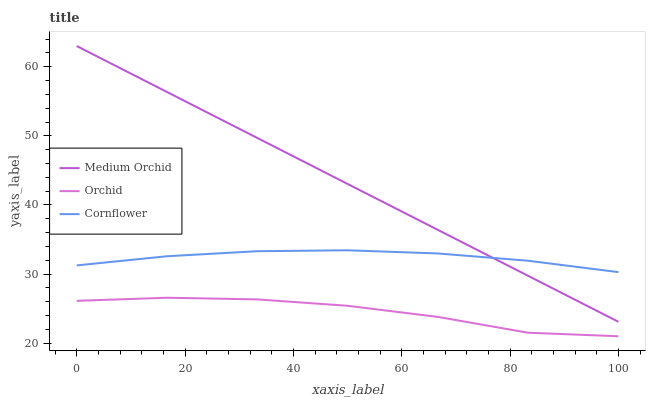Does Orchid have the minimum area under the curve?
Answer yes or no. Yes. Does Medium Orchid have the maximum area under the curve?
Answer yes or no. Yes. Does Medium Orchid have the minimum area under the curve?
Answer yes or no. No. Does Orchid have the maximum area under the curve?
Answer yes or no. No. Is Medium Orchid the smoothest?
Answer yes or no. Yes. Is Orchid the roughest?
Answer yes or no. Yes. Is Orchid the smoothest?
Answer yes or no. No. Is Medium Orchid the roughest?
Answer yes or no. No. Does Orchid have the lowest value?
Answer yes or no. Yes. Does Medium Orchid have the lowest value?
Answer yes or no. No. Does Medium Orchid have the highest value?
Answer yes or no. Yes. Does Orchid have the highest value?
Answer yes or no. No. Is Orchid less than Medium Orchid?
Answer yes or no. Yes. Is Cornflower greater than Orchid?
Answer yes or no. Yes. Does Medium Orchid intersect Cornflower?
Answer yes or no. Yes. Is Medium Orchid less than Cornflower?
Answer yes or no. No. Is Medium Orchid greater than Cornflower?
Answer yes or no. No. Does Orchid intersect Medium Orchid?
Answer yes or no. No. 